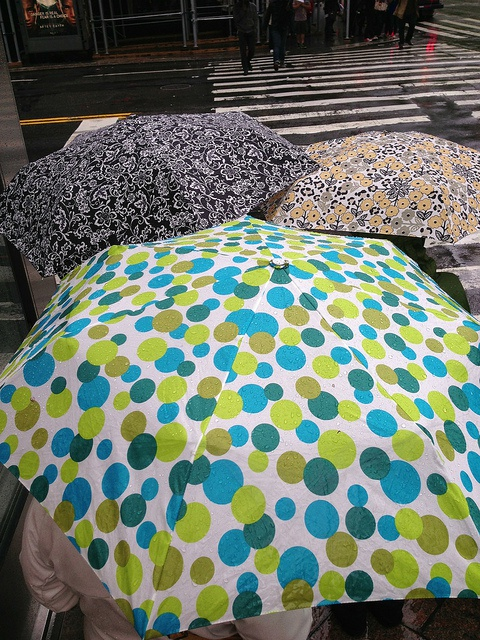Describe the objects in this image and their specific colors. I can see umbrella in black, lavender, darkgray, teal, and olive tones, umbrella in black, gray, darkgray, and lightgray tones, umbrella in black, darkgray, lightgray, gray, and tan tones, people in black, gray, and maroon tones, and people in black, gray, darkgray, and darkgreen tones in this image. 